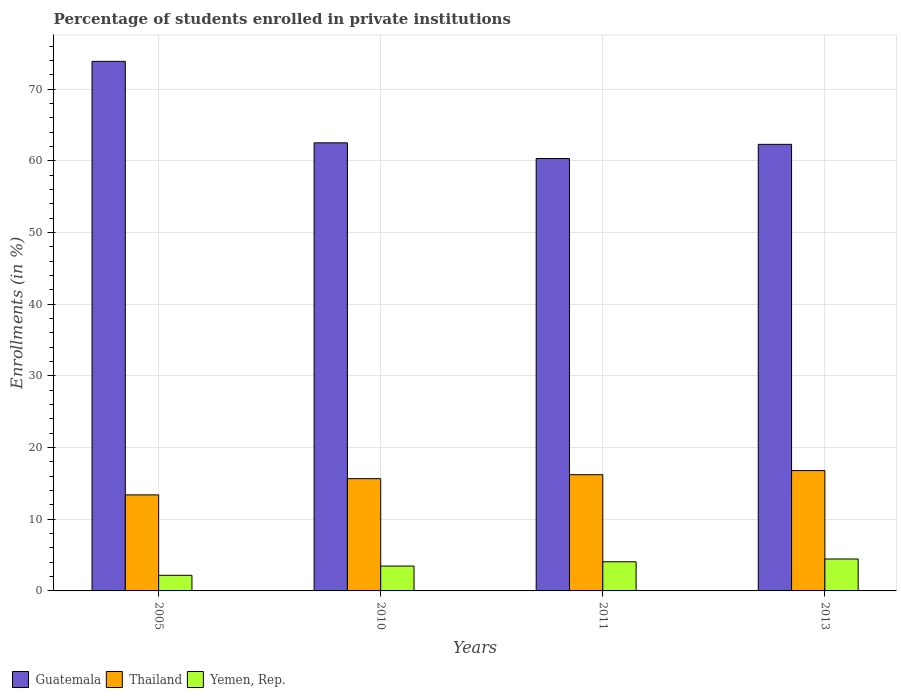How many different coloured bars are there?
Provide a short and direct response. 3. Are the number of bars per tick equal to the number of legend labels?
Make the answer very short. Yes. How many bars are there on the 2nd tick from the right?
Keep it short and to the point. 3. What is the label of the 4th group of bars from the left?
Keep it short and to the point. 2013. What is the percentage of trained teachers in Thailand in 2005?
Make the answer very short. 13.4. Across all years, what is the maximum percentage of trained teachers in Thailand?
Offer a very short reply. 16.78. Across all years, what is the minimum percentage of trained teachers in Guatemala?
Make the answer very short. 60.31. In which year was the percentage of trained teachers in Thailand minimum?
Provide a short and direct response. 2005. What is the total percentage of trained teachers in Yemen, Rep. in the graph?
Keep it short and to the point. 14.17. What is the difference between the percentage of trained teachers in Yemen, Rep. in 2005 and that in 2013?
Make the answer very short. -2.27. What is the difference between the percentage of trained teachers in Guatemala in 2005 and the percentage of trained teachers in Yemen, Rep. in 2013?
Your answer should be compact. 69.41. What is the average percentage of trained teachers in Thailand per year?
Provide a succinct answer. 15.51. In the year 2011, what is the difference between the percentage of trained teachers in Yemen, Rep. and percentage of trained teachers in Guatemala?
Offer a very short reply. -56.24. In how many years, is the percentage of trained teachers in Yemen, Rep. greater than 8 %?
Offer a terse response. 0. What is the ratio of the percentage of trained teachers in Guatemala in 2005 to that in 2010?
Your response must be concise. 1.18. What is the difference between the highest and the second highest percentage of trained teachers in Guatemala?
Your answer should be compact. 11.36. What is the difference between the highest and the lowest percentage of trained teachers in Thailand?
Give a very brief answer. 3.39. In how many years, is the percentage of trained teachers in Thailand greater than the average percentage of trained teachers in Thailand taken over all years?
Provide a succinct answer. 3. What does the 1st bar from the left in 2010 represents?
Offer a very short reply. Guatemala. What does the 3rd bar from the right in 2010 represents?
Your answer should be very brief. Guatemala. Is it the case that in every year, the sum of the percentage of trained teachers in Yemen, Rep. and percentage of trained teachers in Guatemala is greater than the percentage of trained teachers in Thailand?
Provide a succinct answer. Yes. Are all the bars in the graph horizontal?
Offer a terse response. No. What is the difference between two consecutive major ticks on the Y-axis?
Ensure brevity in your answer.  10. Does the graph contain grids?
Your response must be concise. Yes. Where does the legend appear in the graph?
Provide a succinct answer. Bottom left. How many legend labels are there?
Provide a succinct answer. 3. How are the legend labels stacked?
Your response must be concise. Horizontal. What is the title of the graph?
Provide a succinct answer. Percentage of students enrolled in private institutions. Does "Libya" appear as one of the legend labels in the graph?
Offer a very short reply. No. What is the label or title of the X-axis?
Give a very brief answer. Years. What is the label or title of the Y-axis?
Offer a terse response. Enrollments (in %). What is the Enrollments (in %) of Guatemala in 2005?
Provide a succinct answer. 73.86. What is the Enrollments (in %) in Thailand in 2005?
Keep it short and to the point. 13.4. What is the Enrollments (in %) in Yemen, Rep. in 2005?
Your response must be concise. 2.18. What is the Enrollments (in %) of Guatemala in 2010?
Offer a very short reply. 62.5. What is the Enrollments (in %) in Thailand in 2010?
Offer a very short reply. 15.66. What is the Enrollments (in %) in Yemen, Rep. in 2010?
Your answer should be very brief. 3.47. What is the Enrollments (in %) in Guatemala in 2011?
Offer a terse response. 60.31. What is the Enrollments (in %) in Thailand in 2011?
Make the answer very short. 16.21. What is the Enrollments (in %) of Yemen, Rep. in 2011?
Your answer should be compact. 4.07. What is the Enrollments (in %) of Guatemala in 2013?
Your response must be concise. 62.29. What is the Enrollments (in %) of Thailand in 2013?
Give a very brief answer. 16.78. What is the Enrollments (in %) in Yemen, Rep. in 2013?
Keep it short and to the point. 4.45. Across all years, what is the maximum Enrollments (in %) of Guatemala?
Provide a short and direct response. 73.86. Across all years, what is the maximum Enrollments (in %) of Thailand?
Give a very brief answer. 16.78. Across all years, what is the maximum Enrollments (in %) of Yemen, Rep.?
Keep it short and to the point. 4.45. Across all years, what is the minimum Enrollments (in %) of Guatemala?
Offer a very short reply. 60.31. Across all years, what is the minimum Enrollments (in %) in Thailand?
Your answer should be very brief. 13.4. Across all years, what is the minimum Enrollments (in %) of Yemen, Rep.?
Make the answer very short. 2.18. What is the total Enrollments (in %) of Guatemala in the graph?
Offer a very short reply. 258.96. What is the total Enrollments (in %) of Thailand in the graph?
Provide a short and direct response. 62.05. What is the total Enrollments (in %) in Yemen, Rep. in the graph?
Keep it short and to the point. 14.17. What is the difference between the Enrollments (in %) of Guatemala in 2005 and that in 2010?
Offer a terse response. 11.36. What is the difference between the Enrollments (in %) in Thailand in 2005 and that in 2010?
Give a very brief answer. -2.26. What is the difference between the Enrollments (in %) in Yemen, Rep. in 2005 and that in 2010?
Your response must be concise. -1.29. What is the difference between the Enrollments (in %) in Guatemala in 2005 and that in 2011?
Make the answer very short. 13.55. What is the difference between the Enrollments (in %) of Thailand in 2005 and that in 2011?
Give a very brief answer. -2.81. What is the difference between the Enrollments (in %) in Yemen, Rep. in 2005 and that in 2011?
Keep it short and to the point. -1.89. What is the difference between the Enrollments (in %) of Guatemala in 2005 and that in 2013?
Provide a succinct answer. 11.57. What is the difference between the Enrollments (in %) of Thailand in 2005 and that in 2013?
Your answer should be compact. -3.39. What is the difference between the Enrollments (in %) of Yemen, Rep. in 2005 and that in 2013?
Ensure brevity in your answer.  -2.27. What is the difference between the Enrollments (in %) of Guatemala in 2010 and that in 2011?
Offer a very short reply. 2.19. What is the difference between the Enrollments (in %) in Thailand in 2010 and that in 2011?
Ensure brevity in your answer.  -0.55. What is the difference between the Enrollments (in %) of Yemen, Rep. in 2010 and that in 2011?
Provide a succinct answer. -0.6. What is the difference between the Enrollments (in %) in Guatemala in 2010 and that in 2013?
Offer a terse response. 0.21. What is the difference between the Enrollments (in %) of Thailand in 2010 and that in 2013?
Your answer should be very brief. -1.13. What is the difference between the Enrollments (in %) of Yemen, Rep. in 2010 and that in 2013?
Offer a very short reply. -0.98. What is the difference between the Enrollments (in %) in Guatemala in 2011 and that in 2013?
Your response must be concise. -1.98. What is the difference between the Enrollments (in %) in Thailand in 2011 and that in 2013?
Your response must be concise. -0.57. What is the difference between the Enrollments (in %) of Yemen, Rep. in 2011 and that in 2013?
Your response must be concise. -0.39. What is the difference between the Enrollments (in %) of Guatemala in 2005 and the Enrollments (in %) of Thailand in 2010?
Ensure brevity in your answer.  58.2. What is the difference between the Enrollments (in %) in Guatemala in 2005 and the Enrollments (in %) in Yemen, Rep. in 2010?
Keep it short and to the point. 70.39. What is the difference between the Enrollments (in %) in Thailand in 2005 and the Enrollments (in %) in Yemen, Rep. in 2010?
Your answer should be very brief. 9.93. What is the difference between the Enrollments (in %) in Guatemala in 2005 and the Enrollments (in %) in Thailand in 2011?
Provide a succinct answer. 57.65. What is the difference between the Enrollments (in %) of Guatemala in 2005 and the Enrollments (in %) of Yemen, Rep. in 2011?
Make the answer very short. 69.8. What is the difference between the Enrollments (in %) of Thailand in 2005 and the Enrollments (in %) of Yemen, Rep. in 2011?
Keep it short and to the point. 9.33. What is the difference between the Enrollments (in %) in Guatemala in 2005 and the Enrollments (in %) in Thailand in 2013?
Make the answer very short. 57.08. What is the difference between the Enrollments (in %) in Guatemala in 2005 and the Enrollments (in %) in Yemen, Rep. in 2013?
Make the answer very short. 69.41. What is the difference between the Enrollments (in %) in Thailand in 2005 and the Enrollments (in %) in Yemen, Rep. in 2013?
Make the answer very short. 8.94. What is the difference between the Enrollments (in %) of Guatemala in 2010 and the Enrollments (in %) of Thailand in 2011?
Provide a short and direct response. 46.29. What is the difference between the Enrollments (in %) of Guatemala in 2010 and the Enrollments (in %) of Yemen, Rep. in 2011?
Your answer should be compact. 58.43. What is the difference between the Enrollments (in %) in Thailand in 2010 and the Enrollments (in %) in Yemen, Rep. in 2011?
Provide a succinct answer. 11.59. What is the difference between the Enrollments (in %) of Guatemala in 2010 and the Enrollments (in %) of Thailand in 2013?
Give a very brief answer. 45.71. What is the difference between the Enrollments (in %) in Guatemala in 2010 and the Enrollments (in %) in Yemen, Rep. in 2013?
Offer a terse response. 58.04. What is the difference between the Enrollments (in %) of Thailand in 2010 and the Enrollments (in %) of Yemen, Rep. in 2013?
Your answer should be compact. 11.2. What is the difference between the Enrollments (in %) in Guatemala in 2011 and the Enrollments (in %) in Thailand in 2013?
Offer a very short reply. 43.53. What is the difference between the Enrollments (in %) in Guatemala in 2011 and the Enrollments (in %) in Yemen, Rep. in 2013?
Your answer should be very brief. 55.86. What is the difference between the Enrollments (in %) of Thailand in 2011 and the Enrollments (in %) of Yemen, Rep. in 2013?
Your answer should be compact. 11.76. What is the average Enrollments (in %) in Guatemala per year?
Offer a very short reply. 64.74. What is the average Enrollments (in %) in Thailand per year?
Your response must be concise. 15.51. What is the average Enrollments (in %) in Yemen, Rep. per year?
Give a very brief answer. 3.54. In the year 2005, what is the difference between the Enrollments (in %) in Guatemala and Enrollments (in %) in Thailand?
Provide a succinct answer. 60.47. In the year 2005, what is the difference between the Enrollments (in %) of Guatemala and Enrollments (in %) of Yemen, Rep.?
Your answer should be compact. 71.68. In the year 2005, what is the difference between the Enrollments (in %) in Thailand and Enrollments (in %) in Yemen, Rep.?
Provide a short and direct response. 11.21. In the year 2010, what is the difference between the Enrollments (in %) in Guatemala and Enrollments (in %) in Thailand?
Provide a succinct answer. 46.84. In the year 2010, what is the difference between the Enrollments (in %) of Guatemala and Enrollments (in %) of Yemen, Rep.?
Make the answer very short. 59.03. In the year 2010, what is the difference between the Enrollments (in %) in Thailand and Enrollments (in %) in Yemen, Rep.?
Keep it short and to the point. 12.19. In the year 2011, what is the difference between the Enrollments (in %) in Guatemala and Enrollments (in %) in Thailand?
Your answer should be compact. 44.1. In the year 2011, what is the difference between the Enrollments (in %) in Guatemala and Enrollments (in %) in Yemen, Rep.?
Provide a succinct answer. 56.24. In the year 2011, what is the difference between the Enrollments (in %) of Thailand and Enrollments (in %) of Yemen, Rep.?
Provide a short and direct response. 12.14. In the year 2013, what is the difference between the Enrollments (in %) of Guatemala and Enrollments (in %) of Thailand?
Provide a short and direct response. 45.5. In the year 2013, what is the difference between the Enrollments (in %) in Guatemala and Enrollments (in %) in Yemen, Rep.?
Your answer should be compact. 57.84. In the year 2013, what is the difference between the Enrollments (in %) in Thailand and Enrollments (in %) in Yemen, Rep.?
Your answer should be compact. 12.33. What is the ratio of the Enrollments (in %) in Guatemala in 2005 to that in 2010?
Give a very brief answer. 1.18. What is the ratio of the Enrollments (in %) of Thailand in 2005 to that in 2010?
Provide a short and direct response. 0.86. What is the ratio of the Enrollments (in %) of Yemen, Rep. in 2005 to that in 2010?
Provide a short and direct response. 0.63. What is the ratio of the Enrollments (in %) of Guatemala in 2005 to that in 2011?
Make the answer very short. 1.22. What is the ratio of the Enrollments (in %) of Thailand in 2005 to that in 2011?
Offer a terse response. 0.83. What is the ratio of the Enrollments (in %) in Yemen, Rep. in 2005 to that in 2011?
Offer a terse response. 0.54. What is the ratio of the Enrollments (in %) of Guatemala in 2005 to that in 2013?
Give a very brief answer. 1.19. What is the ratio of the Enrollments (in %) in Thailand in 2005 to that in 2013?
Make the answer very short. 0.8. What is the ratio of the Enrollments (in %) in Yemen, Rep. in 2005 to that in 2013?
Ensure brevity in your answer.  0.49. What is the ratio of the Enrollments (in %) of Guatemala in 2010 to that in 2011?
Offer a terse response. 1.04. What is the ratio of the Enrollments (in %) in Thailand in 2010 to that in 2011?
Your answer should be compact. 0.97. What is the ratio of the Enrollments (in %) of Yemen, Rep. in 2010 to that in 2011?
Ensure brevity in your answer.  0.85. What is the ratio of the Enrollments (in %) in Thailand in 2010 to that in 2013?
Your answer should be compact. 0.93. What is the ratio of the Enrollments (in %) of Yemen, Rep. in 2010 to that in 2013?
Keep it short and to the point. 0.78. What is the ratio of the Enrollments (in %) in Guatemala in 2011 to that in 2013?
Offer a very short reply. 0.97. What is the ratio of the Enrollments (in %) of Thailand in 2011 to that in 2013?
Make the answer very short. 0.97. What is the ratio of the Enrollments (in %) in Yemen, Rep. in 2011 to that in 2013?
Your response must be concise. 0.91. What is the difference between the highest and the second highest Enrollments (in %) in Guatemala?
Keep it short and to the point. 11.36. What is the difference between the highest and the second highest Enrollments (in %) in Thailand?
Your answer should be compact. 0.57. What is the difference between the highest and the second highest Enrollments (in %) in Yemen, Rep.?
Make the answer very short. 0.39. What is the difference between the highest and the lowest Enrollments (in %) in Guatemala?
Give a very brief answer. 13.55. What is the difference between the highest and the lowest Enrollments (in %) in Thailand?
Your answer should be compact. 3.39. What is the difference between the highest and the lowest Enrollments (in %) in Yemen, Rep.?
Your answer should be very brief. 2.27. 